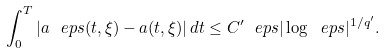<formula> <loc_0><loc_0><loc_500><loc_500>\int _ { 0 } ^ { T } | a _ { \ } e p s ( t , \xi ) - a ( t , \xi ) | \, d t \leq C ^ { \prime } \ e p s | \log \ e p s | ^ { 1 / q ^ { \prime } } .</formula> 